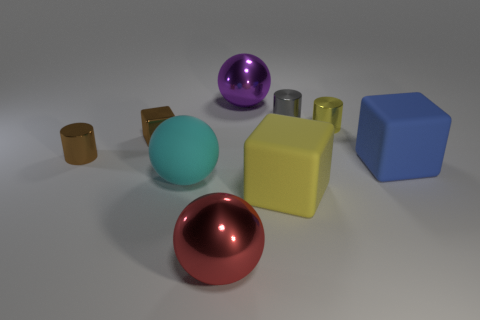There is a blue thing that is the same material as the big cyan thing; what is its size?
Your response must be concise. Large. What size is the brown metallic thing that is the same shape as the small gray object?
Provide a succinct answer. Small. Is there a small brown matte cylinder?
Your response must be concise. No. What number of objects are either small metallic things on the right side of the gray cylinder or tiny metal things?
Provide a short and direct response. 4. What is the material of the blue cube that is the same size as the red sphere?
Keep it short and to the point. Rubber. What color is the large rubber block that is on the right side of the big block on the left side of the yellow metallic thing?
Your answer should be very brief. Blue. How many tiny cubes are left of the red thing?
Provide a short and direct response. 1. What color is the small shiny cube?
Your response must be concise. Brown. What number of tiny objects are either cyan rubber spheres or rubber things?
Your response must be concise. 0. There is a sphere that is behind the big cyan rubber ball; does it have the same color as the small cylinder that is on the left side of the small brown metallic block?
Your answer should be compact. No. 